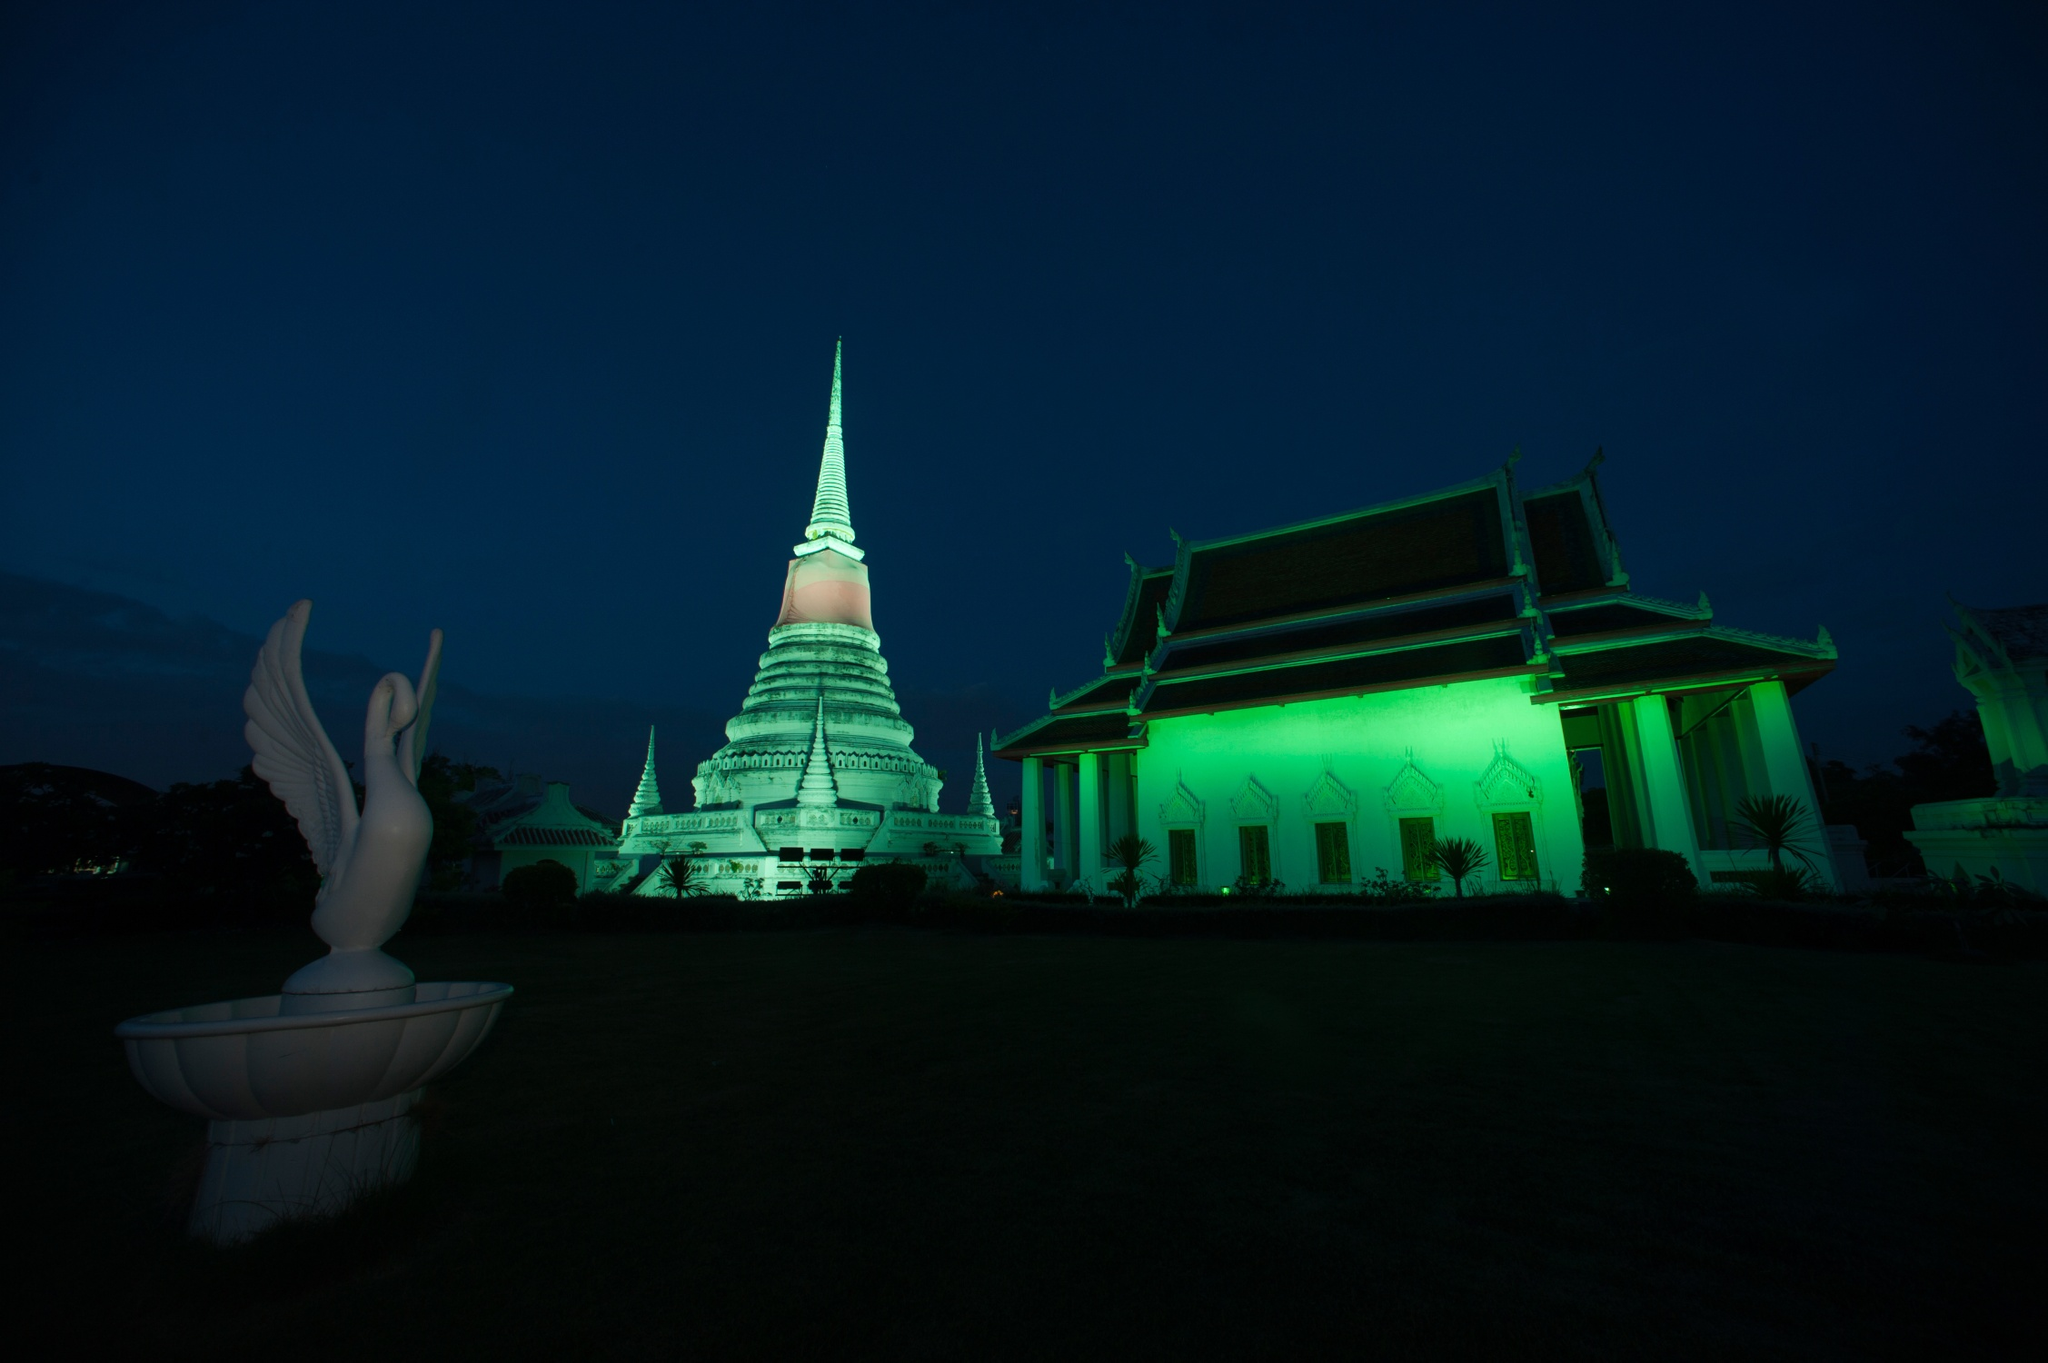Imagine a traveler visiting the temple. What might they encounter? A traveler visiting the temple might encounter a serene and spiritual environment. They’d be greeted by the sight of the beautifully illuminated temple and the majestic bird statue. They might meet monks in saffron robes, meditating or performing rituals. The traveler could witness locals offering incense and prayers, and perhaps join in a guided meditation or a tour that explains the historical and cultural significance of the temple. They may also encounter small shops or stalls offering traditional Thai crafts, souvenirs, and local foods. 